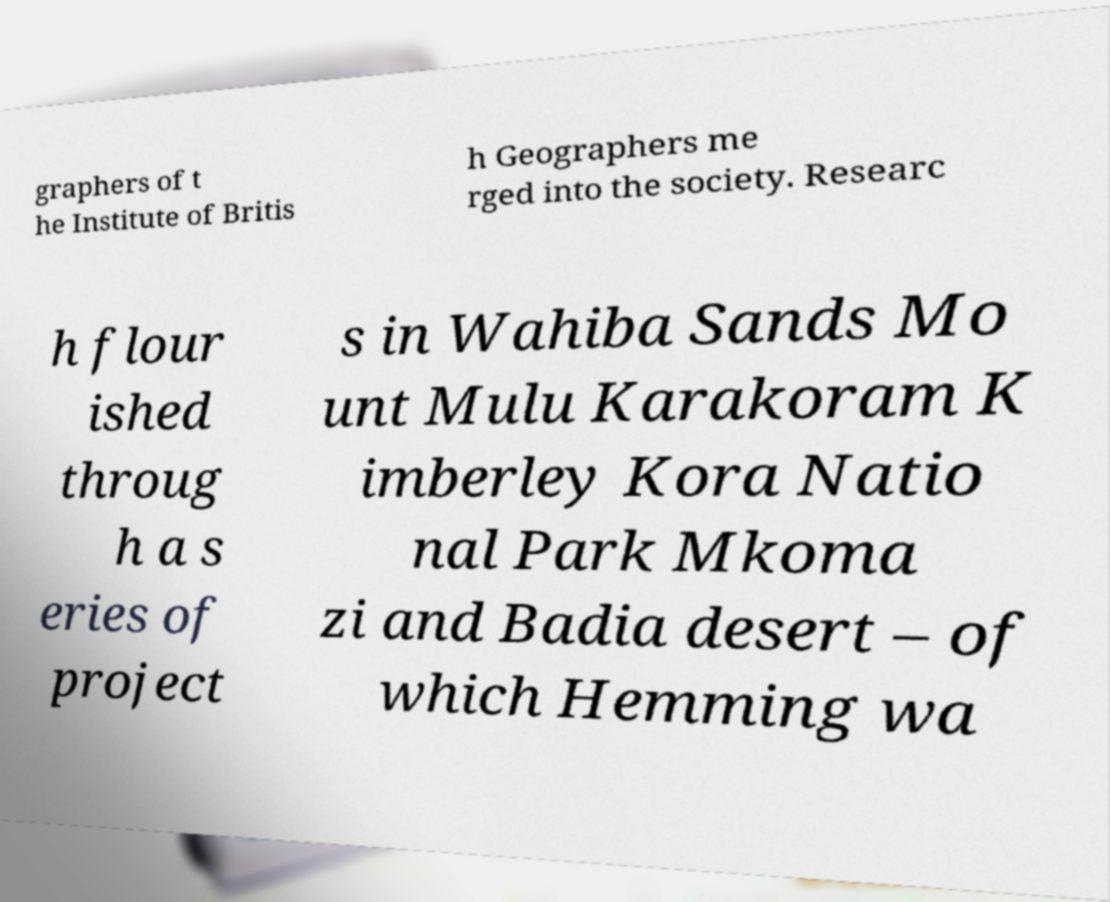For documentation purposes, I need the text within this image transcribed. Could you provide that? graphers of t he Institute of Britis h Geographers me rged into the society. Researc h flour ished throug h a s eries of project s in Wahiba Sands Mo unt Mulu Karakoram K imberley Kora Natio nal Park Mkoma zi and Badia desert – of which Hemming wa 